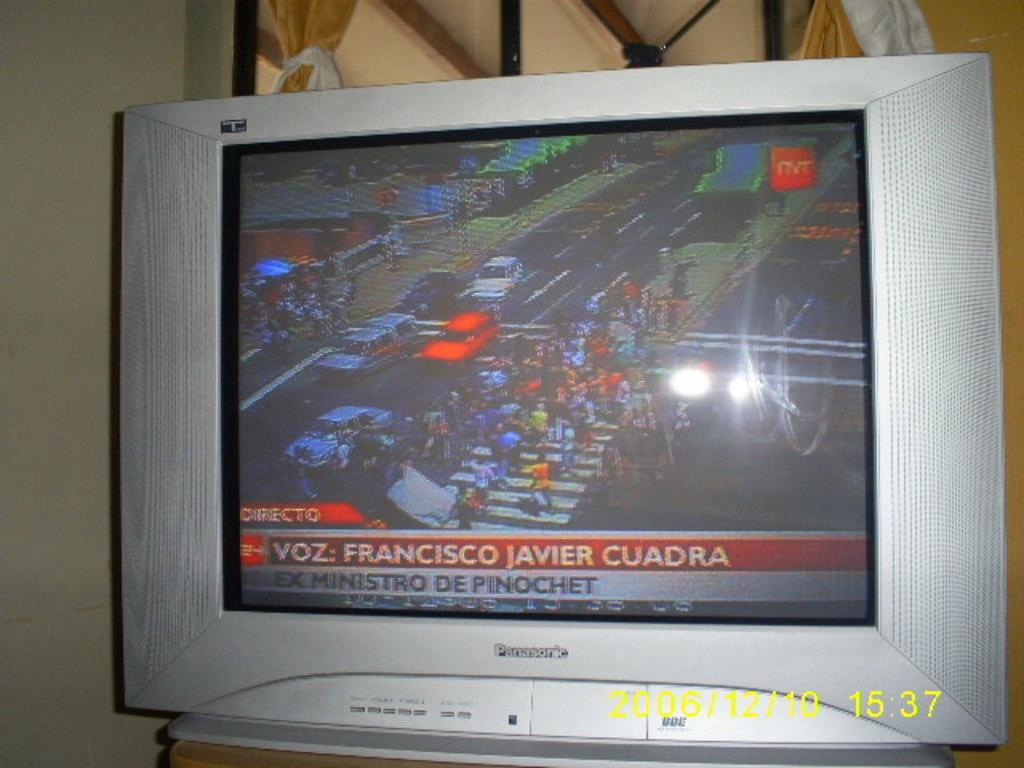<image>
Share a concise interpretation of the image provided. A silver Panasonic television with the news turned on. 